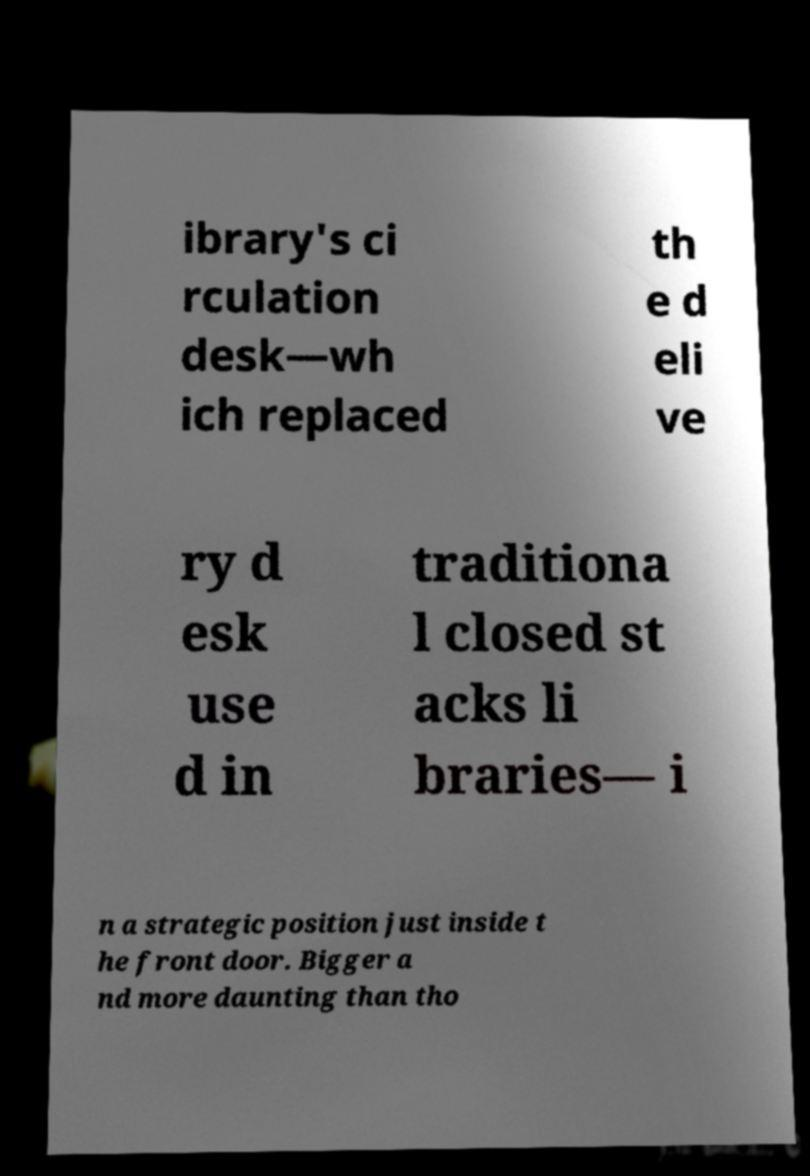Please identify and transcribe the text found in this image. ibrary's ci rculation desk—wh ich replaced th e d eli ve ry d esk use d in traditiona l closed st acks li braries— i n a strategic position just inside t he front door. Bigger a nd more daunting than tho 